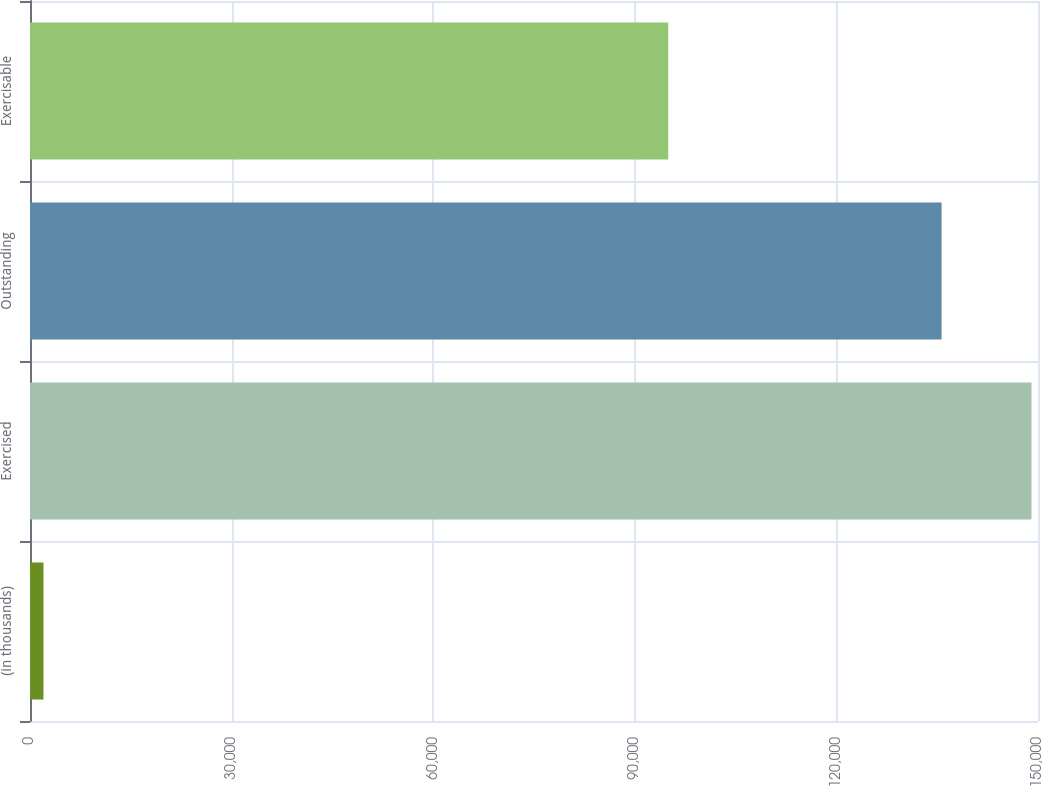<chart> <loc_0><loc_0><loc_500><loc_500><bar_chart><fcel>(in thousands)<fcel>Exercised<fcel>Outstanding<fcel>Exercisable<nl><fcel>2004<fcel>149027<fcel>135652<fcel>94974<nl></chart> 